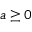Convert formula to latex. <formula><loc_0><loc_0><loc_500><loc_500>a \geq 0</formula> 